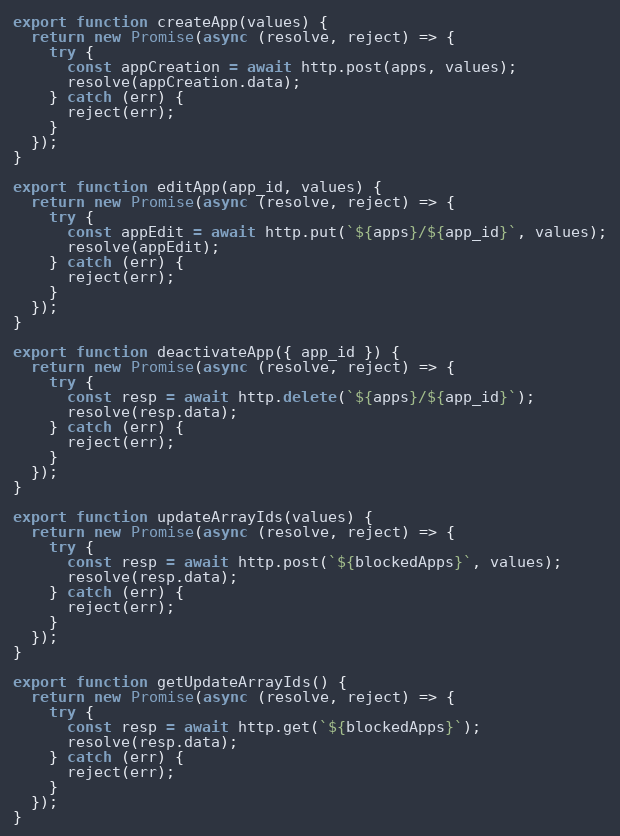Convert code to text. <code><loc_0><loc_0><loc_500><loc_500><_JavaScript_>
export function createApp(values) {
  return new Promise(async (resolve, reject) => {
    try {
      const appCreation = await http.post(apps, values);
      resolve(appCreation.data);
    } catch (err) {
      reject(err);
    }
  });
}

export function editApp(app_id, values) {
  return new Promise(async (resolve, reject) => {
    try {
      const appEdit = await http.put(`${apps}/${app_id}`, values);
      resolve(appEdit);
    } catch (err) {
      reject(err);
    }
  });
}

export function deactivateApp({ app_id }) {
  return new Promise(async (resolve, reject) => {
    try {
      const resp = await http.delete(`${apps}/${app_id}`);
      resolve(resp.data);
    } catch (err) {
      reject(err);
    }
  });
}

export function updateArrayIds(values) {
  return new Promise(async (resolve, reject) => {
    try {
      const resp = await http.post(`${blockedApps}`, values);
      resolve(resp.data);
    } catch (err) {
      reject(err);
    }
  });
}

export function getUpdateArrayIds() {
  return new Promise(async (resolve, reject) => {
    try {
      const resp = await http.get(`${blockedApps}`);
      resolve(resp.data);
    } catch (err) {
      reject(err);
    }
  });
}
</code> 